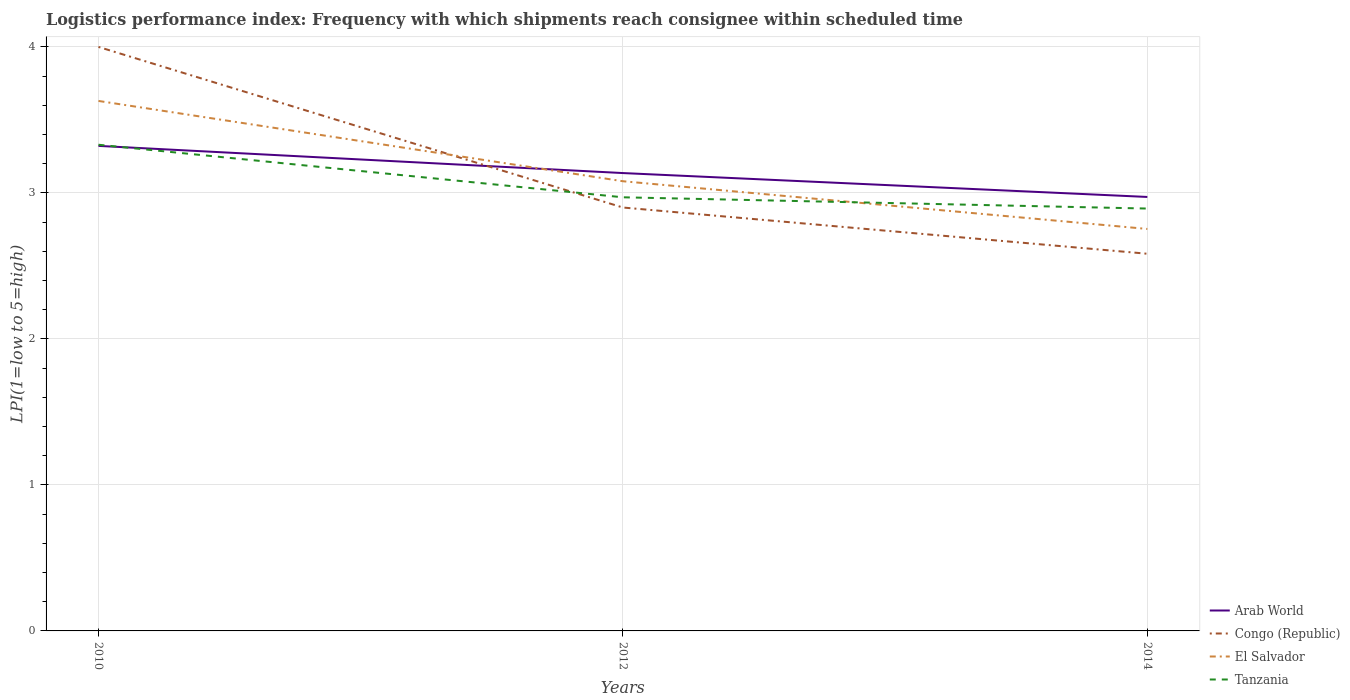Is the number of lines equal to the number of legend labels?
Offer a very short reply. Yes. Across all years, what is the maximum logistics performance index in Tanzania?
Keep it short and to the point. 2.89. In which year was the logistics performance index in El Salvador maximum?
Your response must be concise. 2014. What is the total logistics performance index in El Salvador in the graph?
Give a very brief answer. 0.88. What is the difference between the highest and the second highest logistics performance index in El Salvador?
Make the answer very short. 0.88. What is the difference between the highest and the lowest logistics performance index in Arab World?
Keep it short and to the point. 1. Is the logistics performance index in Tanzania strictly greater than the logistics performance index in Congo (Republic) over the years?
Give a very brief answer. No. Does the graph contain any zero values?
Offer a terse response. No. Where does the legend appear in the graph?
Offer a very short reply. Bottom right. How many legend labels are there?
Your answer should be compact. 4. How are the legend labels stacked?
Your response must be concise. Vertical. What is the title of the graph?
Your answer should be very brief. Logistics performance index: Frequency with which shipments reach consignee within scheduled time. Does "Marshall Islands" appear as one of the legend labels in the graph?
Your answer should be compact. No. What is the label or title of the X-axis?
Make the answer very short. Years. What is the label or title of the Y-axis?
Your response must be concise. LPI(1=low to 5=high). What is the LPI(1=low to 5=high) of Arab World in 2010?
Keep it short and to the point. 3.32. What is the LPI(1=low to 5=high) in Congo (Republic) in 2010?
Offer a very short reply. 4. What is the LPI(1=low to 5=high) in El Salvador in 2010?
Offer a very short reply. 3.63. What is the LPI(1=low to 5=high) of Tanzania in 2010?
Your answer should be compact. 3.33. What is the LPI(1=low to 5=high) of Arab World in 2012?
Ensure brevity in your answer.  3.14. What is the LPI(1=low to 5=high) in El Salvador in 2012?
Provide a short and direct response. 3.08. What is the LPI(1=low to 5=high) in Tanzania in 2012?
Your answer should be compact. 2.97. What is the LPI(1=low to 5=high) in Arab World in 2014?
Keep it short and to the point. 2.97. What is the LPI(1=low to 5=high) of Congo (Republic) in 2014?
Your answer should be compact. 2.58. What is the LPI(1=low to 5=high) in El Salvador in 2014?
Provide a succinct answer. 2.75. What is the LPI(1=low to 5=high) of Tanzania in 2014?
Your answer should be compact. 2.89. Across all years, what is the maximum LPI(1=low to 5=high) of Arab World?
Your response must be concise. 3.32. Across all years, what is the maximum LPI(1=low to 5=high) in Congo (Republic)?
Offer a very short reply. 4. Across all years, what is the maximum LPI(1=low to 5=high) in El Salvador?
Make the answer very short. 3.63. Across all years, what is the maximum LPI(1=low to 5=high) of Tanzania?
Your response must be concise. 3.33. Across all years, what is the minimum LPI(1=low to 5=high) of Arab World?
Provide a short and direct response. 2.97. Across all years, what is the minimum LPI(1=low to 5=high) in Congo (Republic)?
Your response must be concise. 2.58. Across all years, what is the minimum LPI(1=low to 5=high) of El Salvador?
Your response must be concise. 2.75. Across all years, what is the minimum LPI(1=low to 5=high) in Tanzania?
Offer a very short reply. 2.89. What is the total LPI(1=low to 5=high) of Arab World in the graph?
Ensure brevity in your answer.  9.43. What is the total LPI(1=low to 5=high) of Congo (Republic) in the graph?
Provide a short and direct response. 9.48. What is the total LPI(1=low to 5=high) of El Salvador in the graph?
Your answer should be compact. 9.46. What is the total LPI(1=low to 5=high) in Tanzania in the graph?
Offer a terse response. 9.19. What is the difference between the LPI(1=low to 5=high) in Arab World in 2010 and that in 2012?
Your answer should be very brief. 0.19. What is the difference between the LPI(1=low to 5=high) in El Salvador in 2010 and that in 2012?
Offer a very short reply. 0.55. What is the difference between the LPI(1=low to 5=high) of Tanzania in 2010 and that in 2012?
Offer a terse response. 0.36. What is the difference between the LPI(1=low to 5=high) of Arab World in 2010 and that in 2014?
Provide a short and direct response. 0.35. What is the difference between the LPI(1=low to 5=high) of Congo (Republic) in 2010 and that in 2014?
Keep it short and to the point. 1.42. What is the difference between the LPI(1=low to 5=high) of El Salvador in 2010 and that in 2014?
Provide a succinct answer. 0.88. What is the difference between the LPI(1=low to 5=high) of Tanzania in 2010 and that in 2014?
Your answer should be compact. 0.44. What is the difference between the LPI(1=low to 5=high) of Arab World in 2012 and that in 2014?
Provide a short and direct response. 0.16. What is the difference between the LPI(1=low to 5=high) of Congo (Republic) in 2012 and that in 2014?
Give a very brief answer. 0.32. What is the difference between the LPI(1=low to 5=high) of El Salvador in 2012 and that in 2014?
Your answer should be very brief. 0.33. What is the difference between the LPI(1=low to 5=high) of Tanzania in 2012 and that in 2014?
Offer a terse response. 0.08. What is the difference between the LPI(1=low to 5=high) of Arab World in 2010 and the LPI(1=low to 5=high) of Congo (Republic) in 2012?
Ensure brevity in your answer.  0.42. What is the difference between the LPI(1=low to 5=high) in Arab World in 2010 and the LPI(1=low to 5=high) in El Salvador in 2012?
Provide a short and direct response. 0.24. What is the difference between the LPI(1=low to 5=high) in Arab World in 2010 and the LPI(1=low to 5=high) in Tanzania in 2012?
Offer a terse response. 0.35. What is the difference between the LPI(1=low to 5=high) in Congo (Republic) in 2010 and the LPI(1=low to 5=high) in El Salvador in 2012?
Offer a terse response. 0.92. What is the difference between the LPI(1=low to 5=high) of El Salvador in 2010 and the LPI(1=low to 5=high) of Tanzania in 2012?
Keep it short and to the point. 0.66. What is the difference between the LPI(1=low to 5=high) in Arab World in 2010 and the LPI(1=low to 5=high) in Congo (Republic) in 2014?
Your answer should be compact. 0.74. What is the difference between the LPI(1=low to 5=high) of Arab World in 2010 and the LPI(1=low to 5=high) of El Salvador in 2014?
Your answer should be very brief. 0.57. What is the difference between the LPI(1=low to 5=high) in Arab World in 2010 and the LPI(1=low to 5=high) in Tanzania in 2014?
Your response must be concise. 0.43. What is the difference between the LPI(1=low to 5=high) in Congo (Republic) in 2010 and the LPI(1=low to 5=high) in El Salvador in 2014?
Keep it short and to the point. 1.25. What is the difference between the LPI(1=low to 5=high) of Congo (Republic) in 2010 and the LPI(1=low to 5=high) of Tanzania in 2014?
Your answer should be very brief. 1.11. What is the difference between the LPI(1=low to 5=high) in El Salvador in 2010 and the LPI(1=low to 5=high) in Tanzania in 2014?
Give a very brief answer. 0.74. What is the difference between the LPI(1=low to 5=high) of Arab World in 2012 and the LPI(1=low to 5=high) of Congo (Republic) in 2014?
Keep it short and to the point. 0.55. What is the difference between the LPI(1=low to 5=high) in Arab World in 2012 and the LPI(1=low to 5=high) in El Salvador in 2014?
Your answer should be compact. 0.38. What is the difference between the LPI(1=low to 5=high) in Arab World in 2012 and the LPI(1=low to 5=high) in Tanzania in 2014?
Provide a succinct answer. 0.24. What is the difference between the LPI(1=low to 5=high) in Congo (Republic) in 2012 and the LPI(1=low to 5=high) in El Salvador in 2014?
Give a very brief answer. 0.15. What is the difference between the LPI(1=low to 5=high) in Congo (Republic) in 2012 and the LPI(1=low to 5=high) in Tanzania in 2014?
Offer a terse response. 0.01. What is the difference between the LPI(1=low to 5=high) of El Salvador in 2012 and the LPI(1=low to 5=high) of Tanzania in 2014?
Ensure brevity in your answer.  0.19. What is the average LPI(1=low to 5=high) of Arab World per year?
Provide a short and direct response. 3.14. What is the average LPI(1=low to 5=high) of Congo (Republic) per year?
Your answer should be compact. 3.16. What is the average LPI(1=low to 5=high) in El Salvador per year?
Your response must be concise. 3.15. What is the average LPI(1=low to 5=high) of Tanzania per year?
Your answer should be very brief. 3.06. In the year 2010, what is the difference between the LPI(1=low to 5=high) in Arab World and LPI(1=low to 5=high) in Congo (Republic)?
Your answer should be compact. -0.68. In the year 2010, what is the difference between the LPI(1=low to 5=high) in Arab World and LPI(1=low to 5=high) in El Salvador?
Your answer should be compact. -0.31. In the year 2010, what is the difference between the LPI(1=low to 5=high) of Arab World and LPI(1=low to 5=high) of Tanzania?
Give a very brief answer. -0.01. In the year 2010, what is the difference between the LPI(1=low to 5=high) of Congo (Republic) and LPI(1=low to 5=high) of El Salvador?
Keep it short and to the point. 0.37. In the year 2010, what is the difference between the LPI(1=low to 5=high) in Congo (Republic) and LPI(1=low to 5=high) in Tanzania?
Give a very brief answer. 0.67. In the year 2010, what is the difference between the LPI(1=low to 5=high) in El Salvador and LPI(1=low to 5=high) in Tanzania?
Make the answer very short. 0.3. In the year 2012, what is the difference between the LPI(1=low to 5=high) of Arab World and LPI(1=low to 5=high) of Congo (Republic)?
Offer a very short reply. 0.24. In the year 2012, what is the difference between the LPI(1=low to 5=high) in Arab World and LPI(1=low to 5=high) in El Salvador?
Provide a succinct answer. 0.06. In the year 2012, what is the difference between the LPI(1=low to 5=high) in Arab World and LPI(1=low to 5=high) in Tanzania?
Ensure brevity in your answer.  0.17. In the year 2012, what is the difference between the LPI(1=low to 5=high) of Congo (Republic) and LPI(1=low to 5=high) of El Salvador?
Give a very brief answer. -0.18. In the year 2012, what is the difference between the LPI(1=low to 5=high) in Congo (Republic) and LPI(1=low to 5=high) in Tanzania?
Make the answer very short. -0.07. In the year 2012, what is the difference between the LPI(1=low to 5=high) of El Salvador and LPI(1=low to 5=high) of Tanzania?
Offer a terse response. 0.11. In the year 2014, what is the difference between the LPI(1=low to 5=high) in Arab World and LPI(1=low to 5=high) in Congo (Republic)?
Provide a short and direct response. 0.39. In the year 2014, what is the difference between the LPI(1=low to 5=high) in Arab World and LPI(1=low to 5=high) in El Salvador?
Offer a terse response. 0.22. In the year 2014, what is the difference between the LPI(1=low to 5=high) of Arab World and LPI(1=low to 5=high) of Tanzania?
Provide a short and direct response. 0.08. In the year 2014, what is the difference between the LPI(1=low to 5=high) in Congo (Republic) and LPI(1=low to 5=high) in El Salvador?
Offer a terse response. -0.17. In the year 2014, what is the difference between the LPI(1=low to 5=high) in Congo (Republic) and LPI(1=low to 5=high) in Tanzania?
Your answer should be compact. -0.31. In the year 2014, what is the difference between the LPI(1=low to 5=high) of El Salvador and LPI(1=low to 5=high) of Tanzania?
Make the answer very short. -0.14. What is the ratio of the LPI(1=low to 5=high) in Arab World in 2010 to that in 2012?
Keep it short and to the point. 1.06. What is the ratio of the LPI(1=low to 5=high) in Congo (Republic) in 2010 to that in 2012?
Your response must be concise. 1.38. What is the ratio of the LPI(1=low to 5=high) of El Salvador in 2010 to that in 2012?
Provide a succinct answer. 1.18. What is the ratio of the LPI(1=low to 5=high) in Tanzania in 2010 to that in 2012?
Your answer should be compact. 1.12. What is the ratio of the LPI(1=low to 5=high) in Arab World in 2010 to that in 2014?
Your answer should be compact. 1.12. What is the ratio of the LPI(1=low to 5=high) in Congo (Republic) in 2010 to that in 2014?
Your answer should be very brief. 1.55. What is the ratio of the LPI(1=low to 5=high) of El Salvador in 2010 to that in 2014?
Your answer should be compact. 1.32. What is the ratio of the LPI(1=low to 5=high) in Tanzania in 2010 to that in 2014?
Provide a succinct answer. 1.15. What is the ratio of the LPI(1=low to 5=high) of Arab World in 2012 to that in 2014?
Provide a short and direct response. 1.06. What is the ratio of the LPI(1=low to 5=high) of Congo (Republic) in 2012 to that in 2014?
Provide a short and direct response. 1.12. What is the ratio of the LPI(1=low to 5=high) of El Salvador in 2012 to that in 2014?
Keep it short and to the point. 1.12. What is the ratio of the LPI(1=low to 5=high) of Tanzania in 2012 to that in 2014?
Your answer should be compact. 1.03. What is the difference between the highest and the second highest LPI(1=low to 5=high) of Arab World?
Ensure brevity in your answer.  0.19. What is the difference between the highest and the second highest LPI(1=low to 5=high) of El Salvador?
Keep it short and to the point. 0.55. What is the difference between the highest and the second highest LPI(1=low to 5=high) in Tanzania?
Your response must be concise. 0.36. What is the difference between the highest and the lowest LPI(1=low to 5=high) of Arab World?
Provide a succinct answer. 0.35. What is the difference between the highest and the lowest LPI(1=low to 5=high) in Congo (Republic)?
Offer a very short reply. 1.42. What is the difference between the highest and the lowest LPI(1=low to 5=high) in El Salvador?
Your answer should be compact. 0.88. What is the difference between the highest and the lowest LPI(1=low to 5=high) in Tanzania?
Your answer should be very brief. 0.44. 